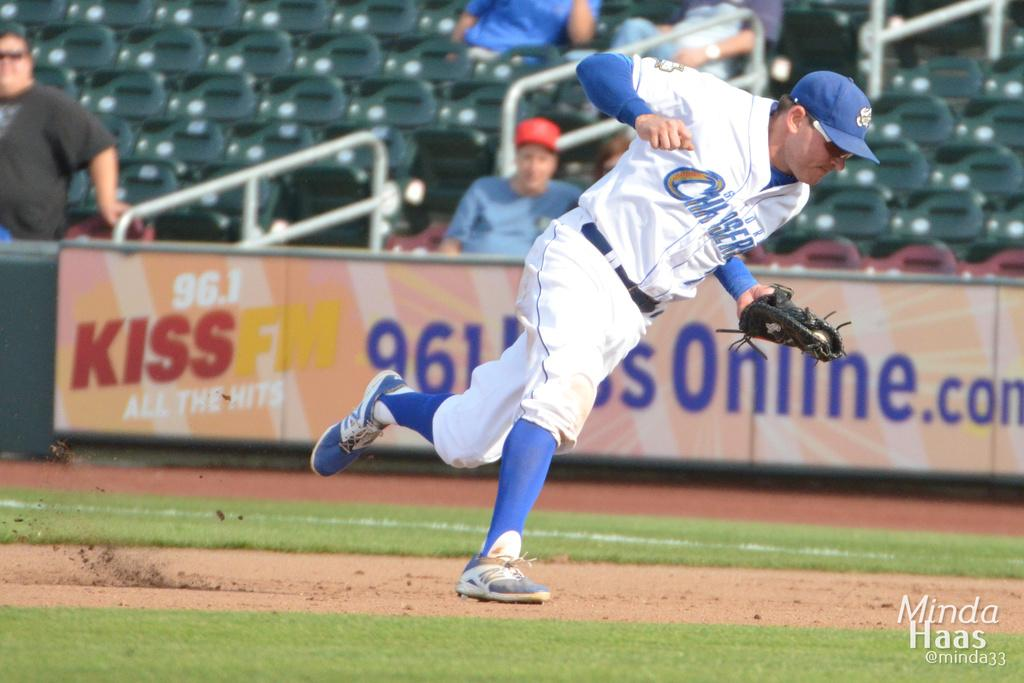<image>
Provide a brief description of the given image. Baseball player for the Chasers running on the field. 